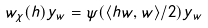Convert formula to latex. <formula><loc_0><loc_0><loc_500><loc_500>w _ { \chi } ( h ) y _ { w } = \psi ( \langle h w , w \rangle / 2 ) y _ { w }</formula> 